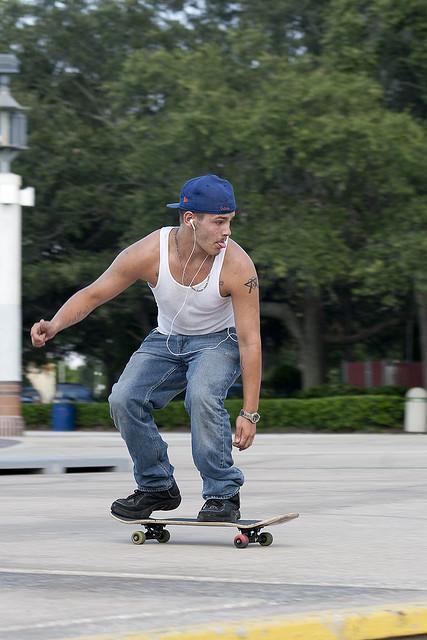How many tattoos can be seen on this man's body?
Give a very brief answer. 1. 